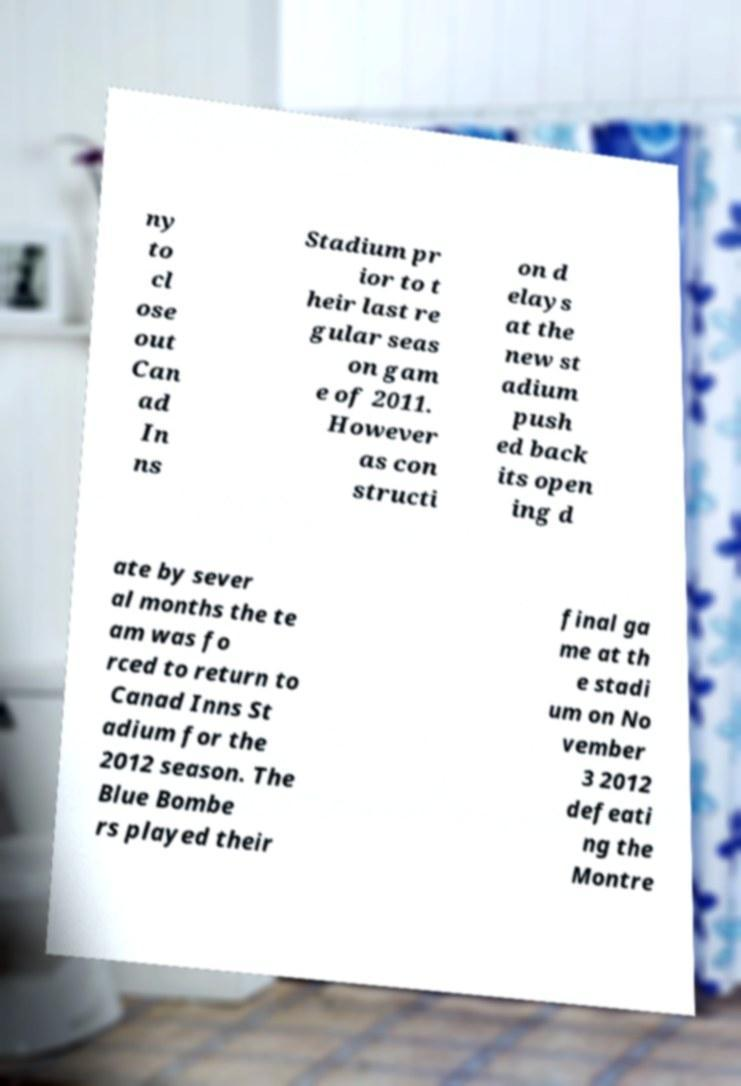Can you read and provide the text displayed in the image?This photo seems to have some interesting text. Can you extract and type it out for me? ny to cl ose out Can ad In ns Stadium pr ior to t heir last re gular seas on gam e of 2011. However as con structi on d elays at the new st adium push ed back its open ing d ate by sever al months the te am was fo rced to return to Canad Inns St adium for the 2012 season. The Blue Bombe rs played their final ga me at th e stadi um on No vember 3 2012 defeati ng the Montre 